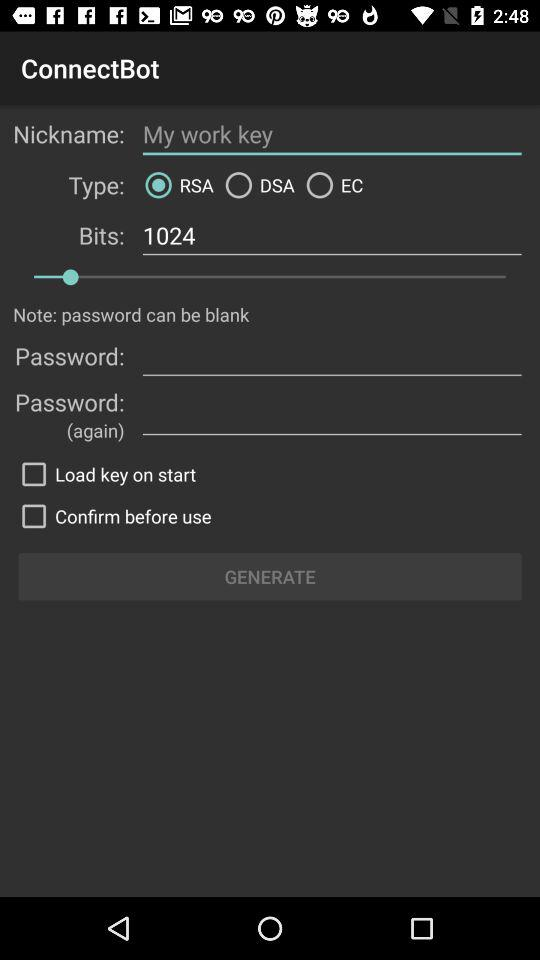What is the number of bits? The number of bits is 1024. 